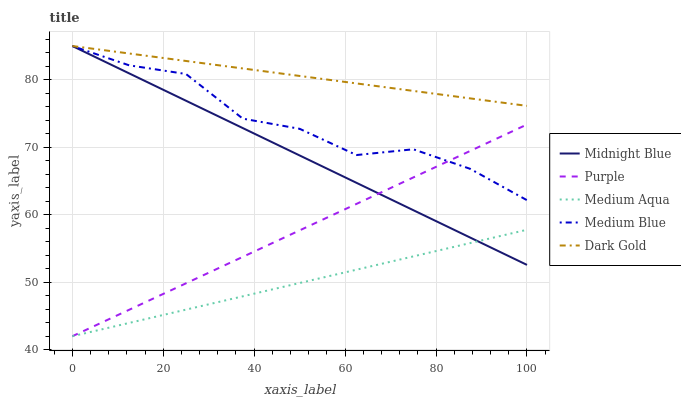Does Medium Blue have the minimum area under the curve?
Answer yes or no. No. Does Medium Blue have the maximum area under the curve?
Answer yes or no. No. Is Medium Blue the smoothest?
Answer yes or no. No. Is Medium Aqua the roughest?
Answer yes or no. No. Does Medium Blue have the lowest value?
Answer yes or no. No. Does Medium Aqua have the highest value?
Answer yes or no. No. Is Medium Aqua less than Dark Gold?
Answer yes or no. Yes. Is Medium Blue greater than Medium Aqua?
Answer yes or no. Yes. Does Medium Aqua intersect Dark Gold?
Answer yes or no. No. 